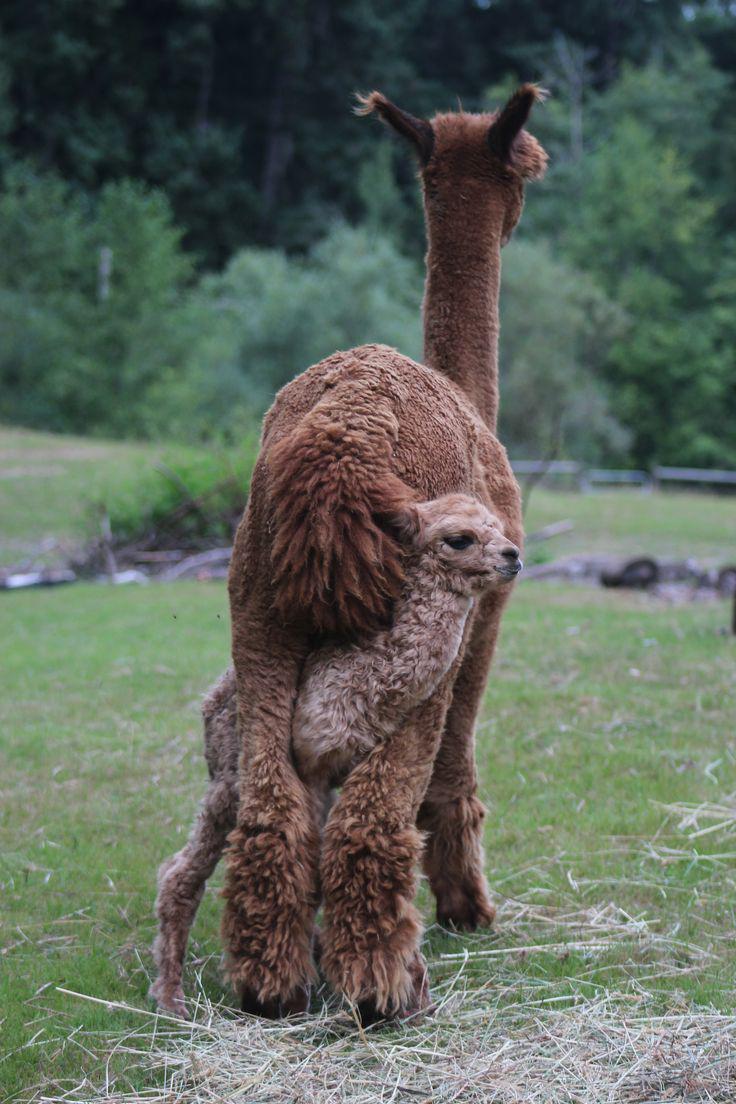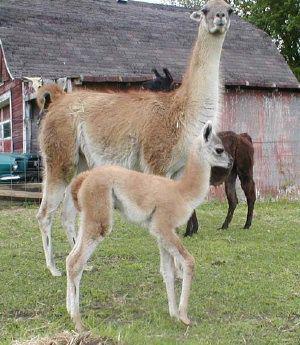The first image is the image on the left, the second image is the image on the right. Evaluate the accuracy of this statement regarding the images: "Each image features exactly two llamas in the foreground.". Is it true? Answer yes or no. Yes. The first image is the image on the left, the second image is the image on the right. Considering the images on both sides, is "Two llamas have brown ears." valid? Answer yes or no. Yes. 